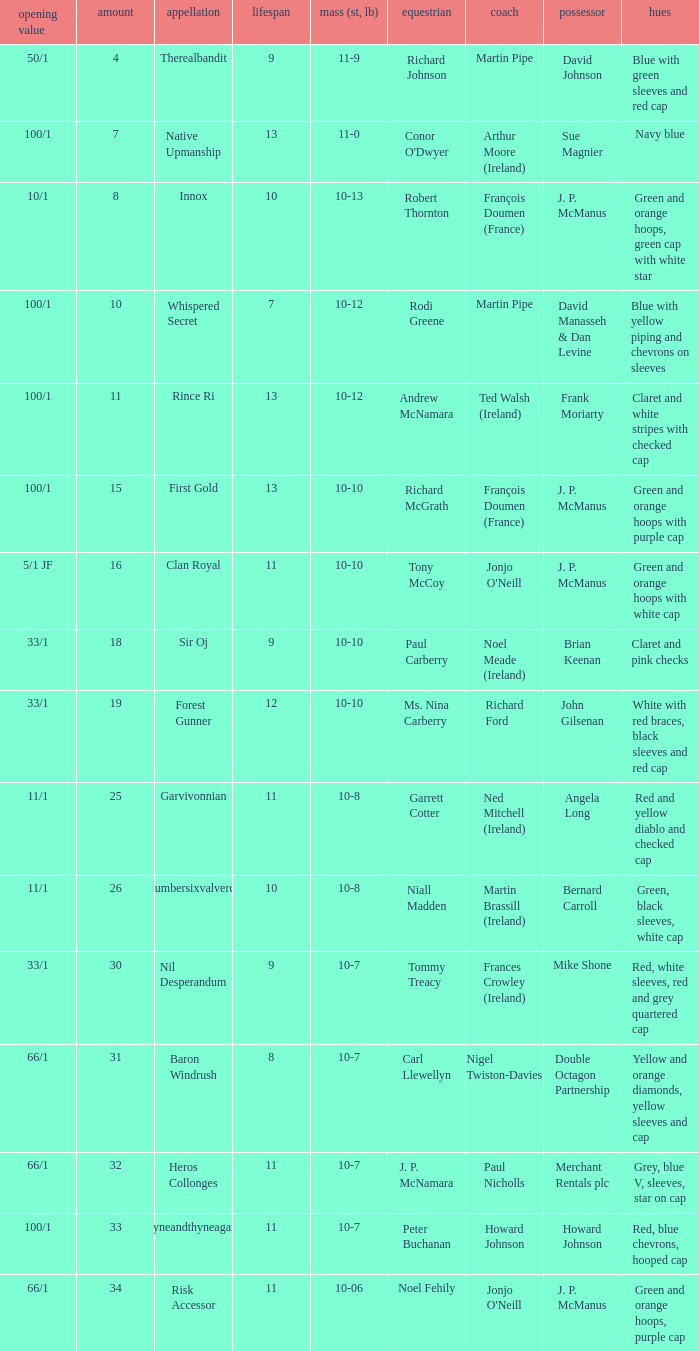What was the name that had a starting price of 11/1 and a jockey named Garrett Cotter? Garvivonnian. 